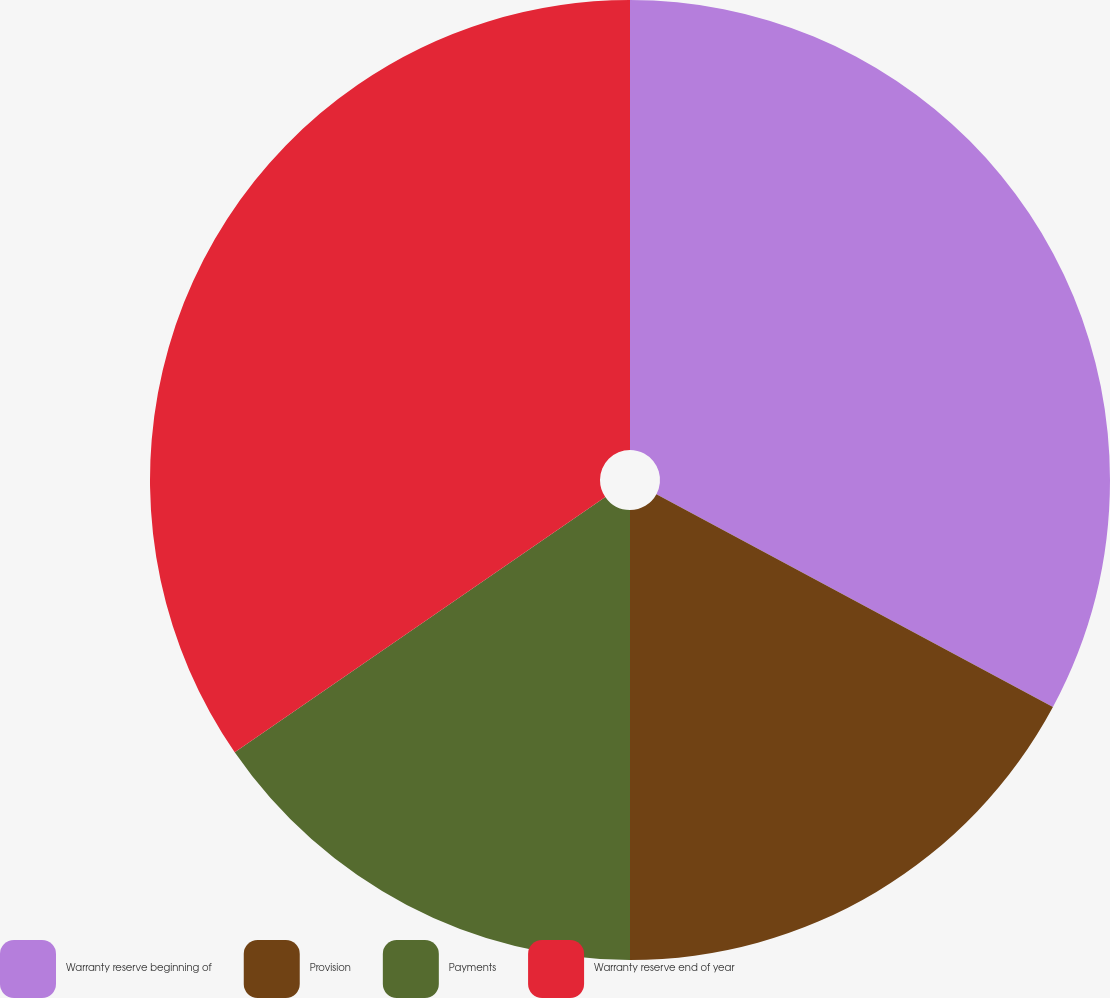Convert chart. <chart><loc_0><loc_0><loc_500><loc_500><pie_chart><fcel>Warranty reserve beginning of<fcel>Provision<fcel>Payments<fcel>Warranty reserve end of year<nl><fcel>32.84%<fcel>17.16%<fcel>15.4%<fcel>34.6%<nl></chart> 